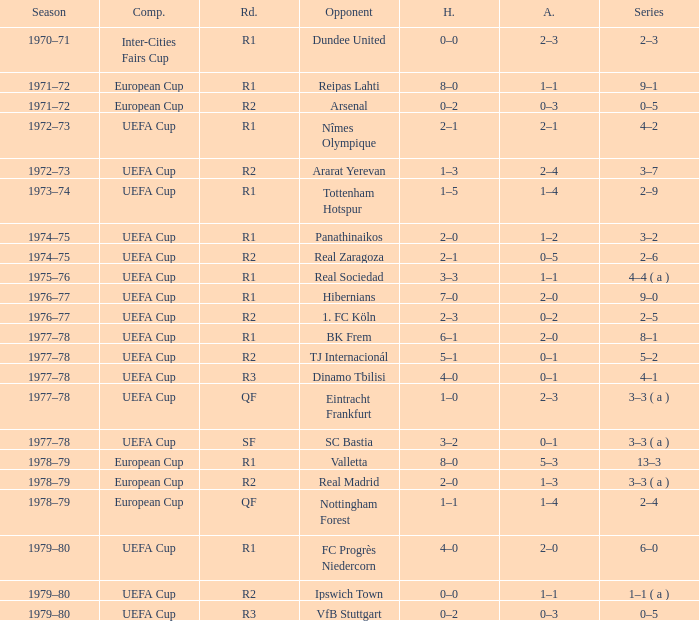Which Round has a Competition of uefa cup, and a Series of 5–2? R2. 